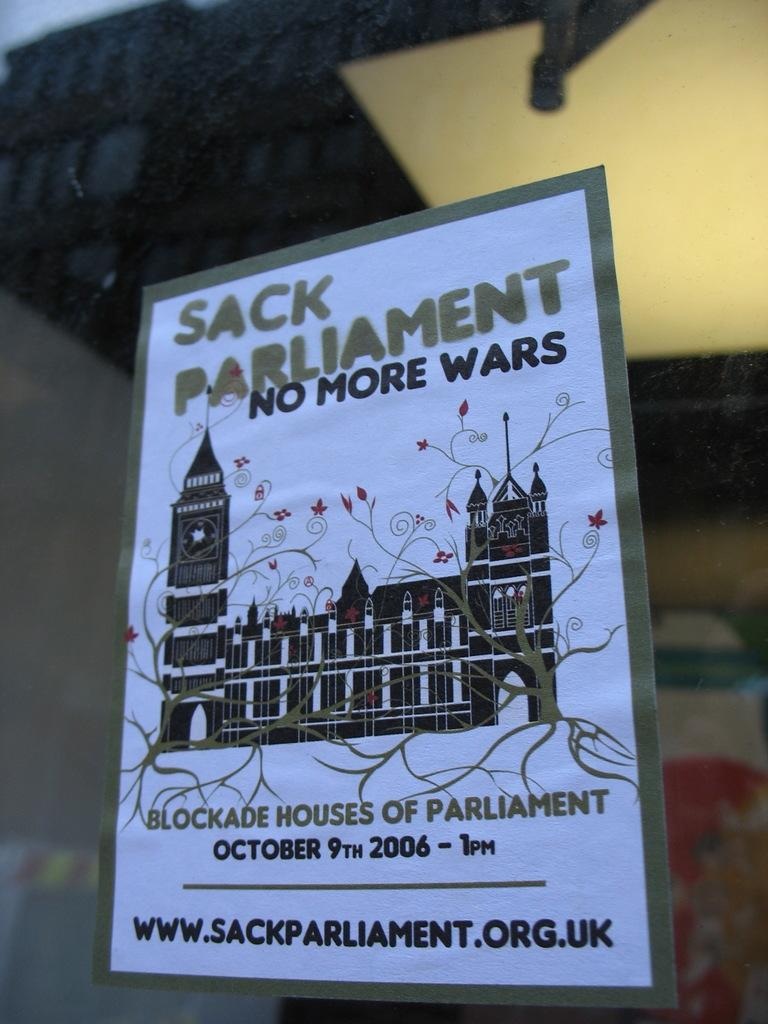<image>
Provide a brief description of the given image. Stuck on a window is a poster for an upcoming event on October 9th 2006 at 1 PM to blockade houses of parliament. 